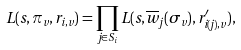<formula> <loc_0><loc_0><loc_500><loc_500>L ( s , \pi _ { v } , r _ { i , v } ) = \prod _ { j \in S _ { i } } L ( s , \overline { w } _ { j } ( \sigma _ { v } ) , r ^ { \prime } _ { i ( j ) , v } ) ,</formula> 